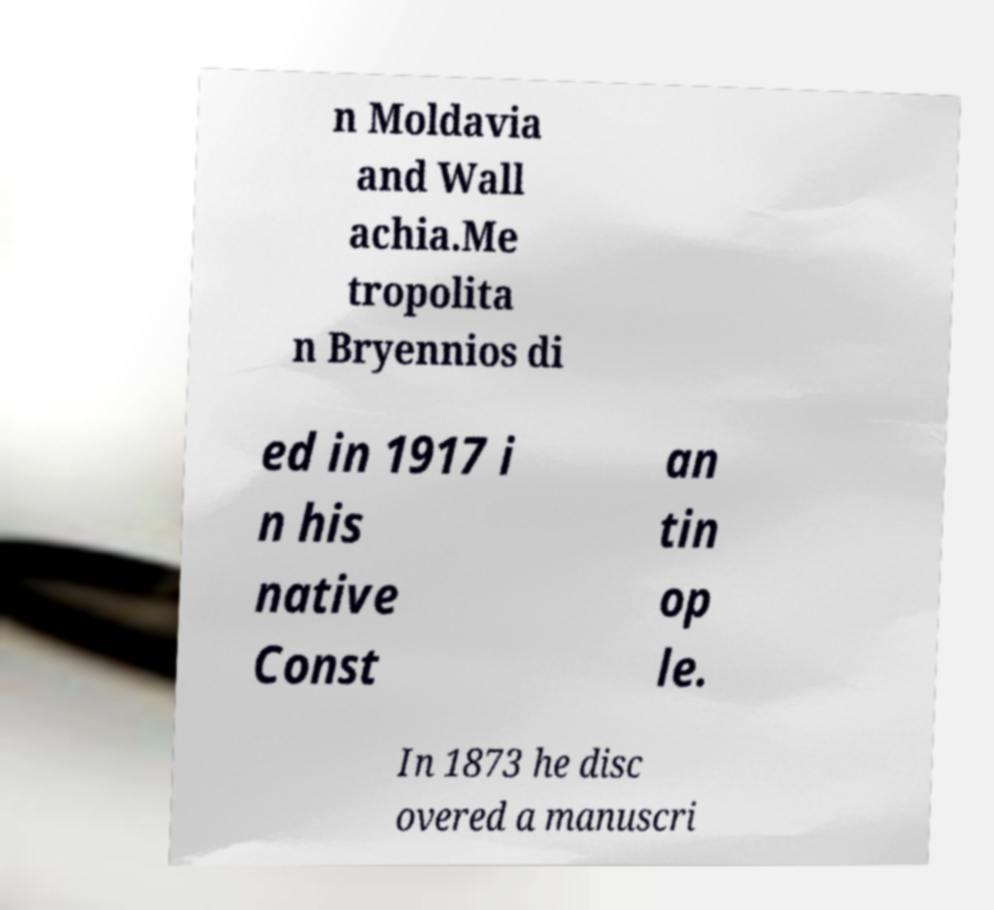There's text embedded in this image that I need extracted. Can you transcribe it verbatim? n Moldavia and Wall achia.Me tropolita n Bryennios di ed in 1917 i n his native Const an tin op le. In 1873 he disc overed a manuscri 